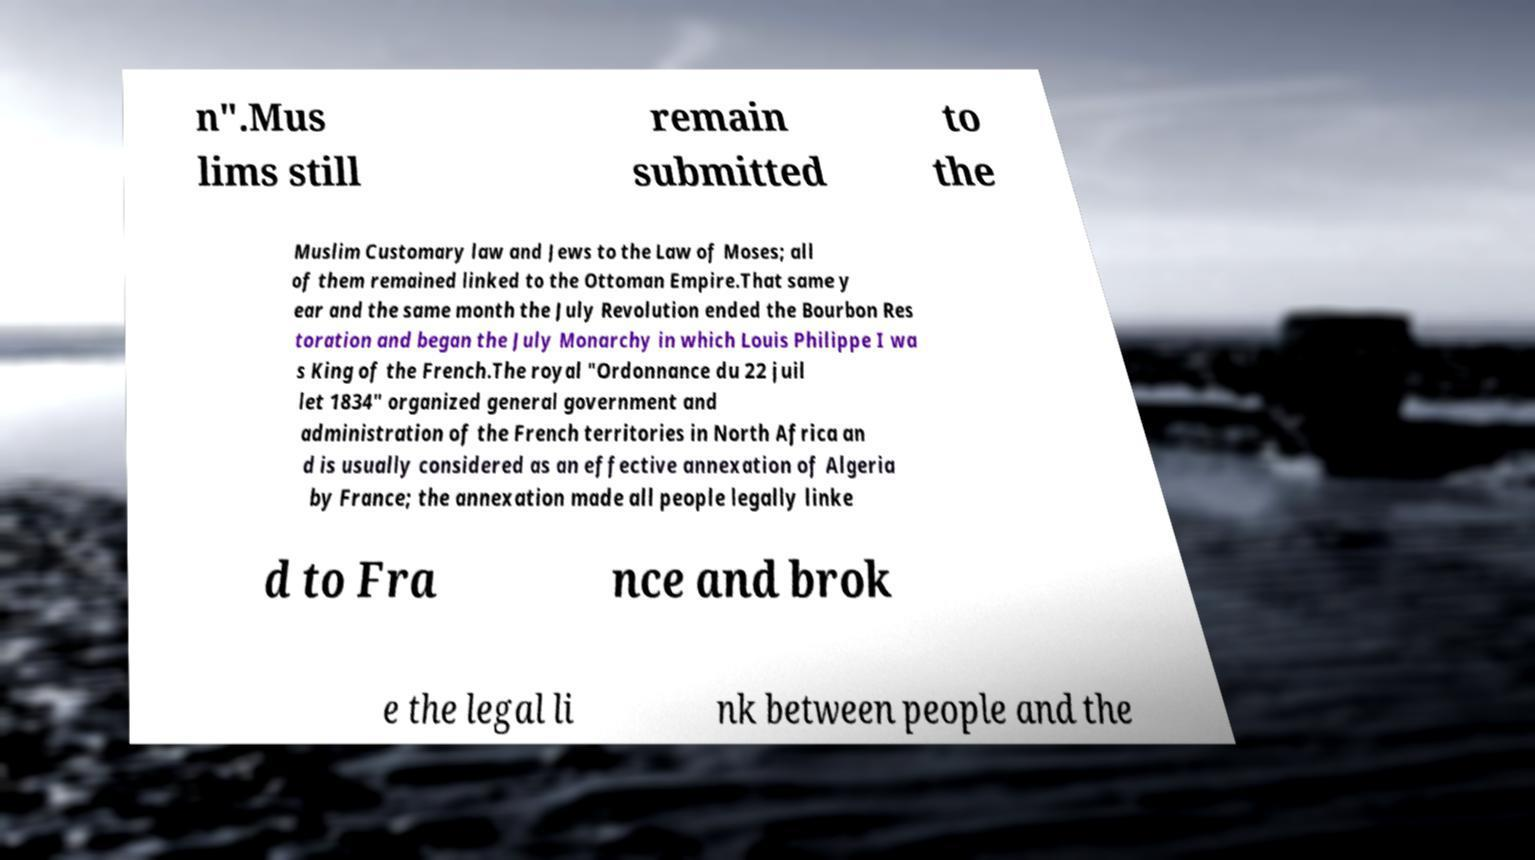Please read and relay the text visible in this image. What does it say? n".Mus lims still remain submitted to the Muslim Customary law and Jews to the Law of Moses; all of them remained linked to the Ottoman Empire.That same y ear and the same month the July Revolution ended the Bourbon Res toration and began the July Monarchy in which Louis Philippe I wa s King of the French.The royal "Ordonnance du 22 juil let 1834" organized general government and administration of the French territories in North Africa an d is usually considered as an effective annexation of Algeria by France; the annexation made all people legally linke d to Fra nce and brok e the legal li nk between people and the 